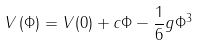Convert formula to latex. <formula><loc_0><loc_0><loc_500><loc_500>V \left ( \Phi \right ) = V ( 0 ) + c \Phi - \frac { 1 } { 6 } g \Phi ^ { 3 }</formula> 